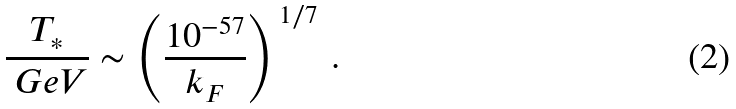<formula> <loc_0><loc_0><loc_500><loc_500>\frac { T _ { * } } { \ G e V } \sim \left ( \frac { 1 0 ^ { - 5 7 } } { k _ { F } } \right ) ^ { \, 1 / 7 } \, .</formula> 